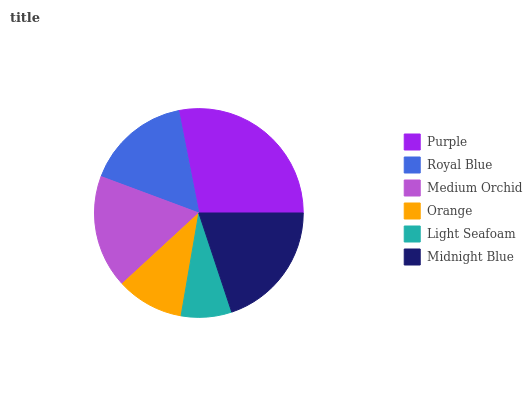Is Light Seafoam the minimum?
Answer yes or no. Yes. Is Purple the maximum?
Answer yes or no. Yes. Is Royal Blue the minimum?
Answer yes or no. No. Is Royal Blue the maximum?
Answer yes or no. No. Is Purple greater than Royal Blue?
Answer yes or no. Yes. Is Royal Blue less than Purple?
Answer yes or no. Yes. Is Royal Blue greater than Purple?
Answer yes or no. No. Is Purple less than Royal Blue?
Answer yes or no. No. Is Medium Orchid the high median?
Answer yes or no. Yes. Is Royal Blue the low median?
Answer yes or no. Yes. Is Royal Blue the high median?
Answer yes or no. No. Is Midnight Blue the low median?
Answer yes or no. No. 